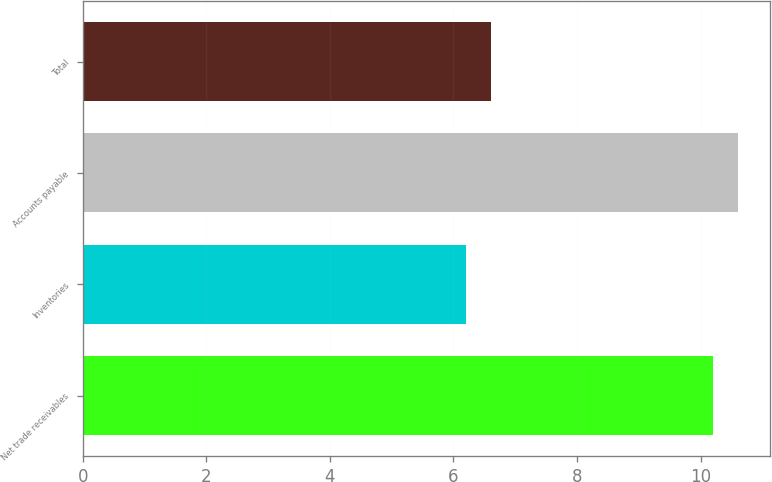Convert chart to OTSL. <chart><loc_0><loc_0><loc_500><loc_500><bar_chart><fcel>Net trade receivables<fcel>Inventories<fcel>Accounts payable<fcel>Total<nl><fcel>10.2<fcel>6.2<fcel>10.6<fcel>6.6<nl></chart> 